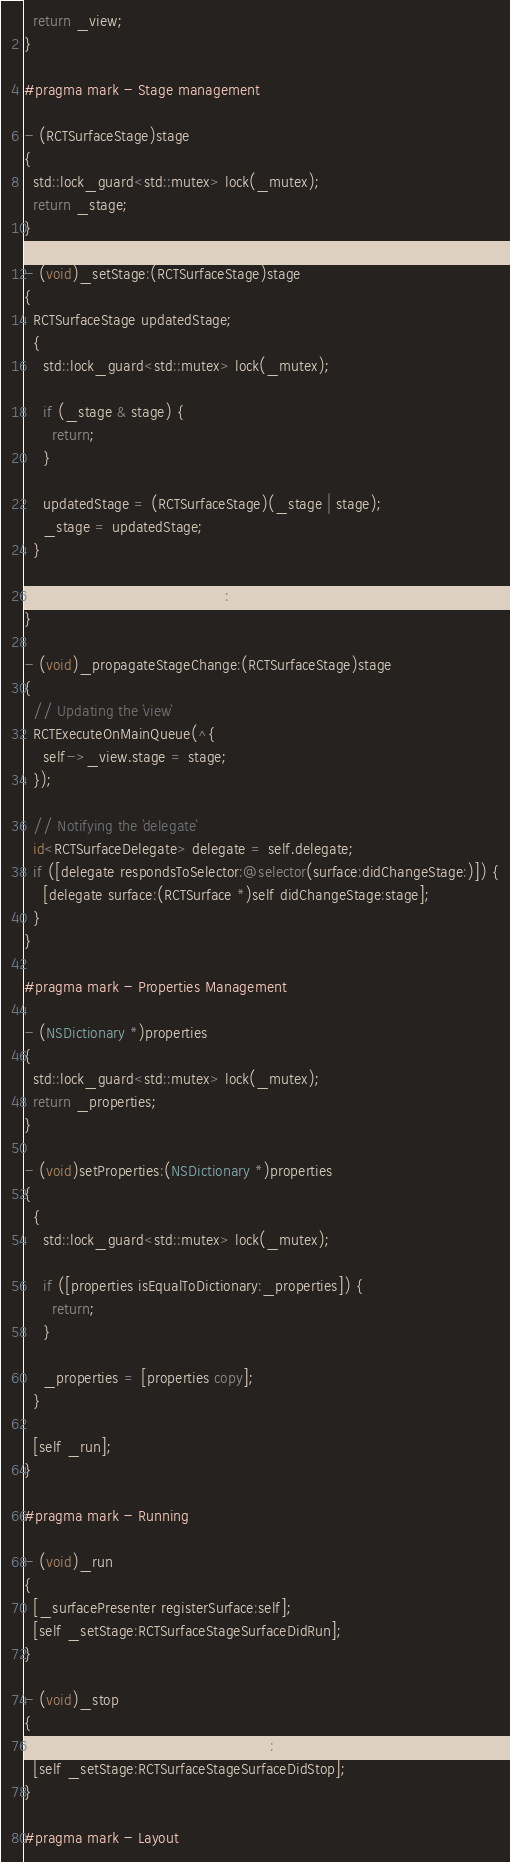Convert code to text. <code><loc_0><loc_0><loc_500><loc_500><_ObjectiveC_>  return _view;
}

#pragma mark - Stage management

- (RCTSurfaceStage)stage
{
  std::lock_guard<std::mutex> lock(_mutex);
  return _stage;
}

- (void)_setStage:(RCTSurfaceStage)stage
{
  RCTSurfaceStage updatedStage;
  {
    std::lock_guard<std::mutex> lock(_mutex);

    if (_stage & stage) {
      return;
    }

    updatedStage = (RCTSurfaceStage)(_stage | stage);
    _stage = updatedStage;
  }

  [self _propagateStageChange:updatedStage];
}

- (void)_propagateStageChange:(RCTSurfaceStage)stage
{
  // Updating the `view`
  RCTExecuteOnMainQueue(^{
    self->_view.stage = stage;
  });

  // Notifying the `delegate`
  id<RCTSurfaceDelegate> delegate = self.delegate;
  if ([delegate respondsToSelector:@selector(surface:didChangeStage:)]) {
    [delegate surface:(RCTSurface *)self didChangeStage:stage];
  }
}

#pragma mark - Properties Management

- (NSDictionary *)properties
{
  std::lock_guard<std::mutex> lock(_mutex);
  return _properties;
}

- (void)setProperties:(NSDictionary *)properties
{
  {
    std::lock_guard<std::mutex> lock(_mutex);

    if ([properties isEqualToDictionary:_properties]) {
      return;
    }

    _properties = [properties copy];
  }

  [self _run];
}

#pragma mark - Running

- (void)_run
{
  [_surfacePresenter registerSurface:self];
  [self _setStage:RCTSurfaceStageSurfaceDidRun];
}

- (void)_stop
{
  [_surfacePresenter unregisterSurface:self];
  [self _setStage:RCTSurfaceStageSurfaceDidStop];
}

#pragma mark - Layout
</code> 